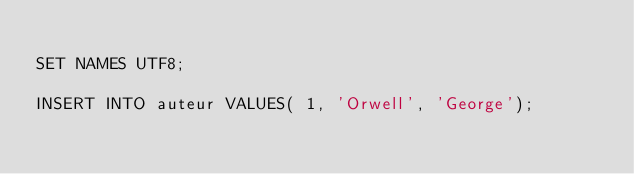Convert code to text. <code><loc_0><loc_0><loc_500><loc_500><_SQL_>
SET NAMES UTF8;

INSERT INTO auteur VALUES( 1, 'Orwell', 'George');</code> 